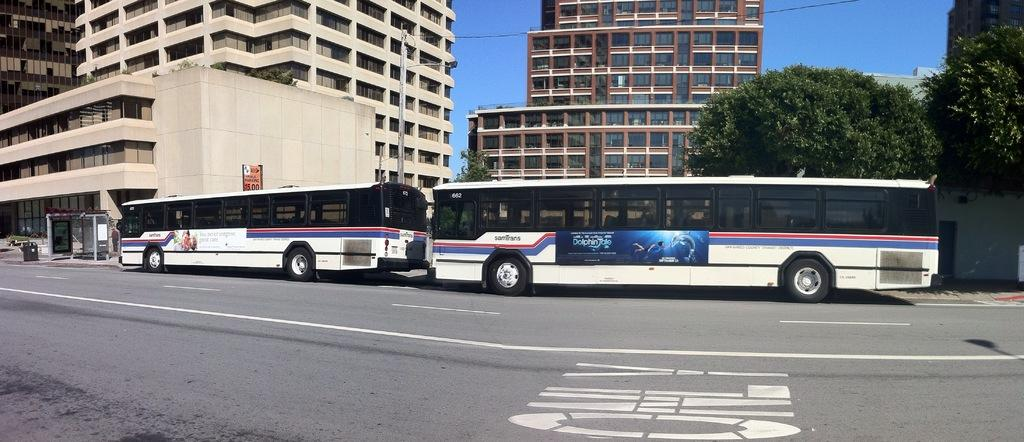How many buses are parked on the road in the image? There are two buses parked on the road in the image. What can be seen in the background of the image? In the background, there are buildings, a bus station, a pole, wires, trees, and the sky. What is the purpose of the bus station in the image? The bus station in the background is likely a place for passengers to board or disembark from buses. What are the wires attached to in the background? The wires are attached to the pole in the background. Where can the linen be found in the image? There is no linen present in the image. What type of branch is holding up the shelf in the image? There is no shelf or branch present in the image. 